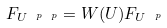Convert formula to latex. <formula><loc_0><loc_0><loc_500><loc_500>F _ { U ^ { \ p \ p } } = W ( U ) F _ { U ^ { \ p } }</formula> 